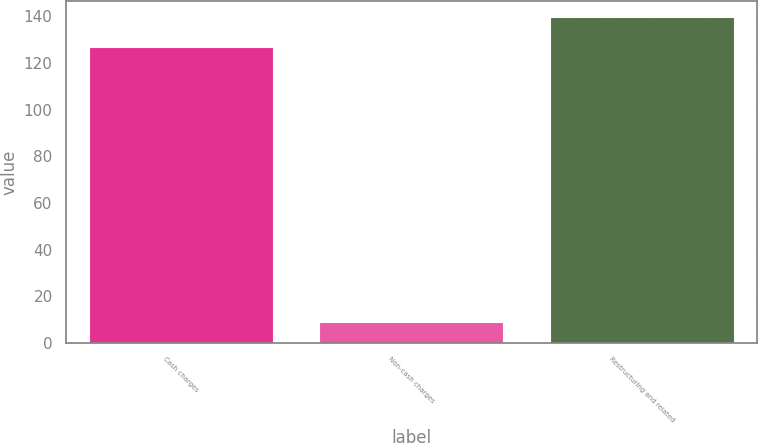Convert chart to OTSL. <chart><loc_0><loc_0><loc_500><loc_500><bar_chart><fcel>Cash charges<fcel>Non-cash charges<fcel>Restructuring and related<nl><fcel>127<fcel>9<fcel>139.7<nl></chart> 